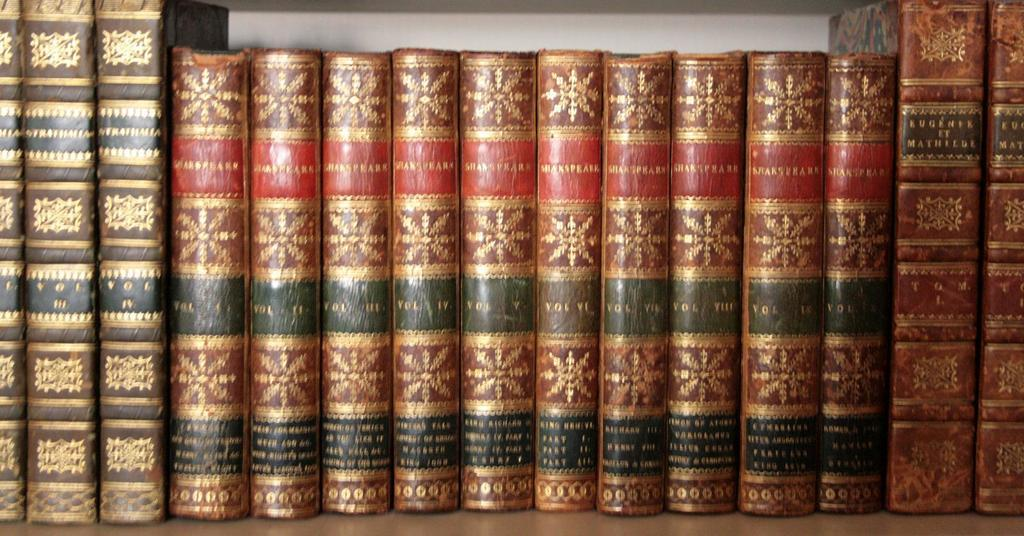What type of objects can be seen in the image? There are many book spines visible in the image. Where are the book spines located? The book spines are on a bookshelf. What type of patch can be seen on the book spines in the image? There is no patch visible on the book spines in the image. 